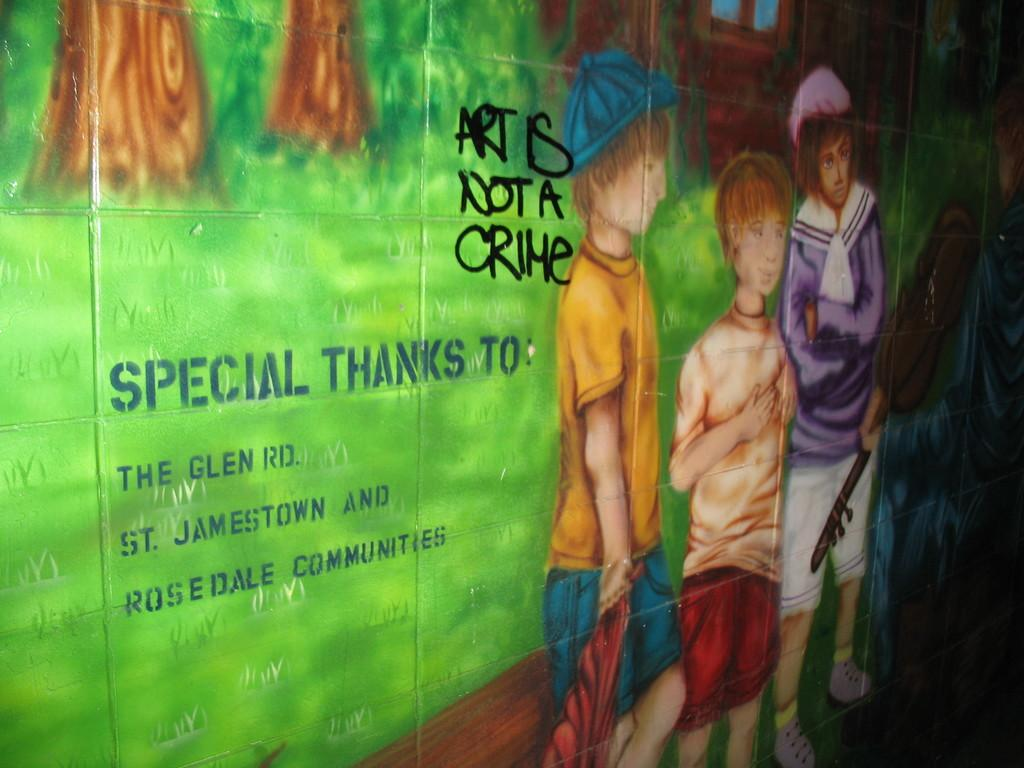What is one of the main features in the image? There is a wall in the image. How many boys are depicted in the painting? There are three boys in the painting. What type of natural elements can be seen in the image? There are trees in the image. Is there any text or writing present in the image? Yes, there is text or writing present in the image. What type of animal can be seen crossing the bridge in the image? There is no bridge or animal present in the image. Is the painting on a canvas? The facts provided do not mention the medium of the painting, so we cannot determine if it is on a canvas or not. 